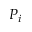Convert formula to latex. <formula><loc_0><loc_0><loc_500><loc_500>P _ { i }</formula> 